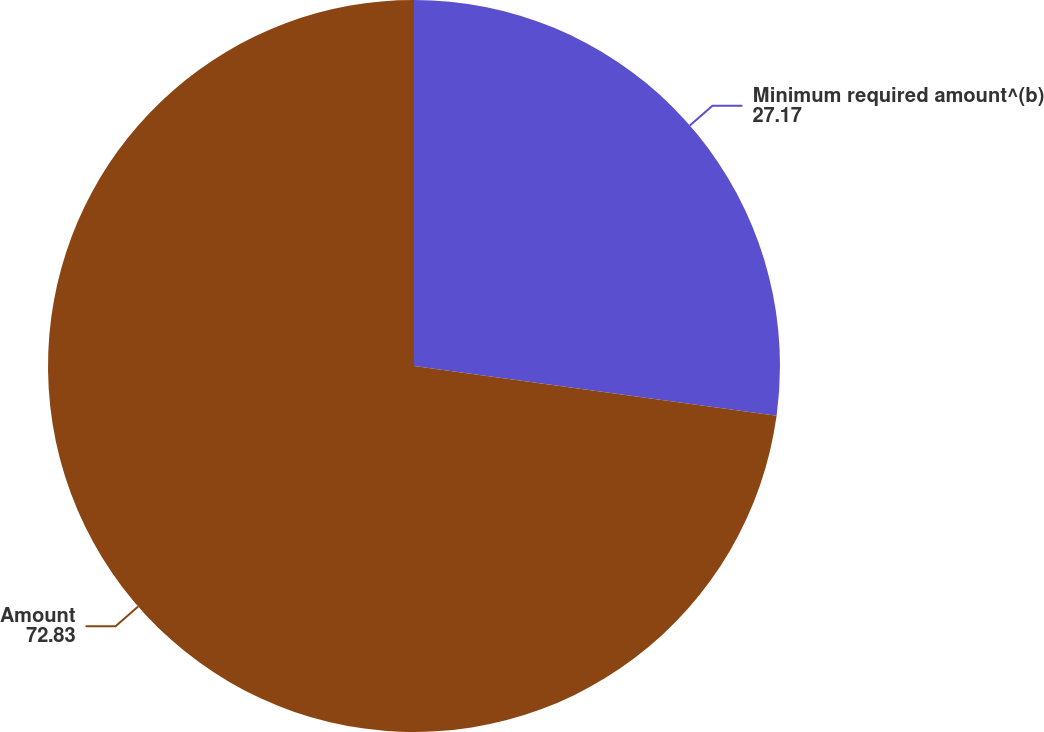Convert chart to OTSL. <chart><loc_0><loc_0><loc_500><loc_500><pie_chart><fcel>Minimum required amount^(b)<fcel>Amount<nl><fcel>27.17%<fcel>72.83%<nl></chart> 